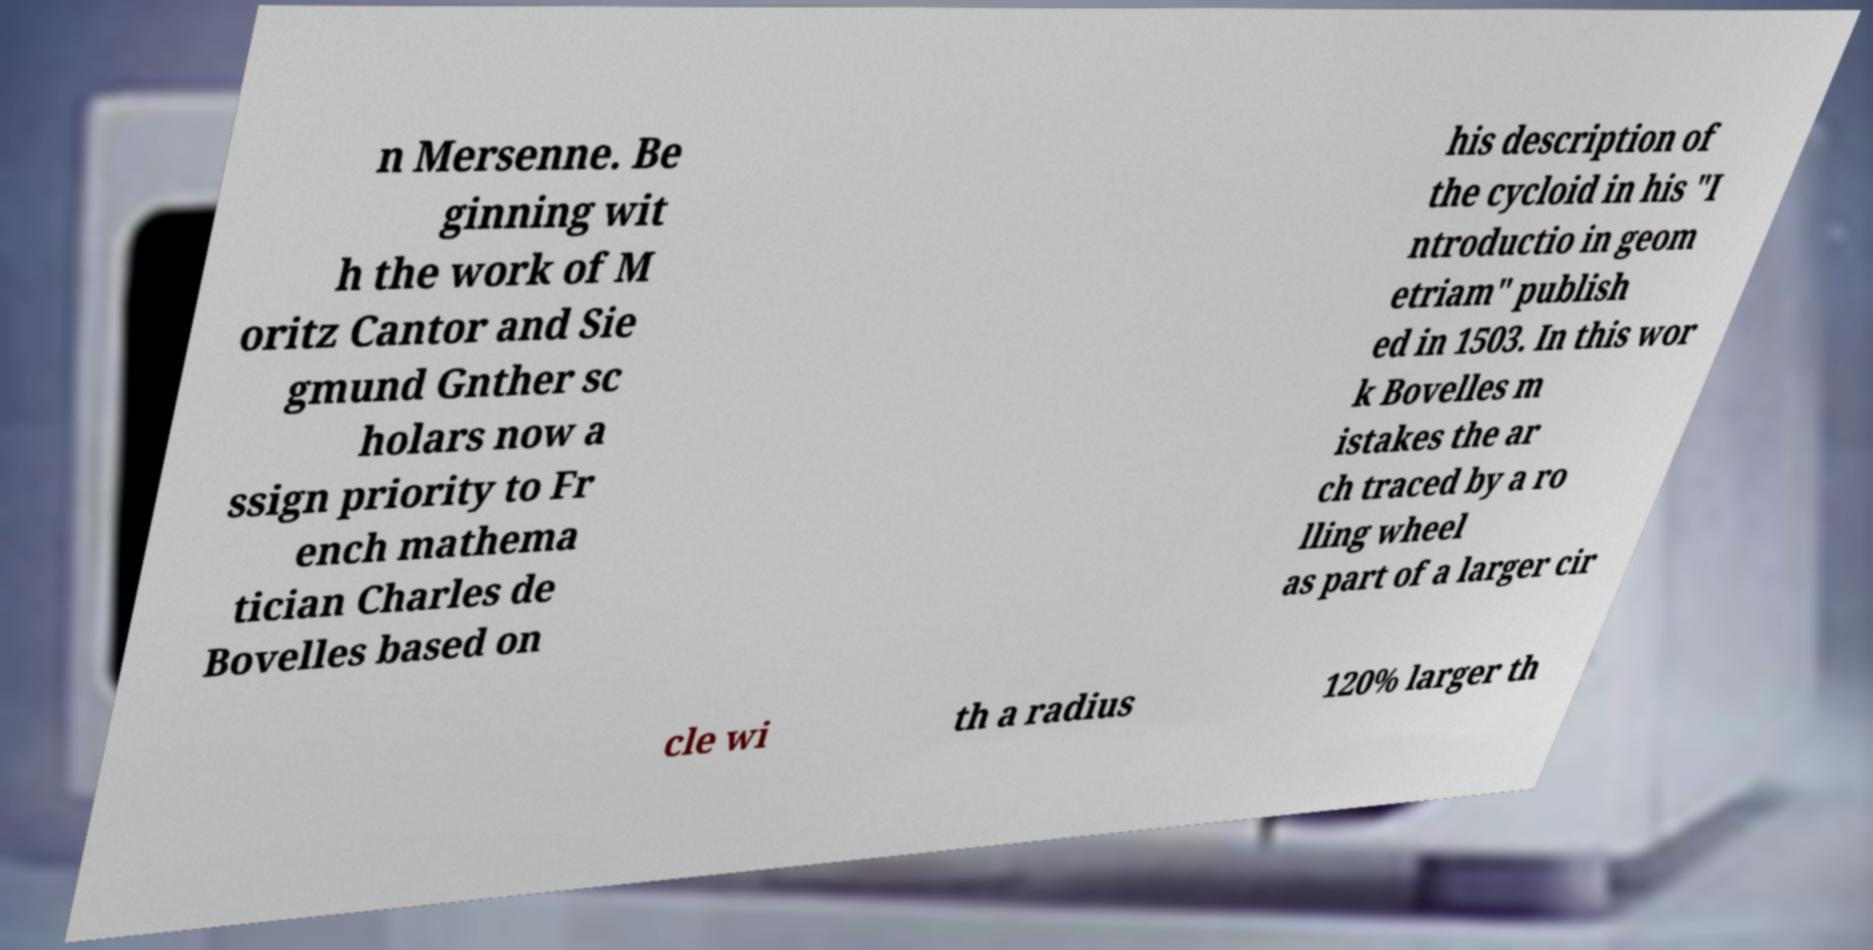Please identify and transcribe the text found in this image. n Mersenne. Be ginning wit h the work of M oritz Cantor and Sie gmund Gnther sc holars now a ssign priority to Fr ench mathema tician Charles de Bovelles based on his description of the cycloid in his "I ntroductio in geom etriam" publish ed in 1503. In this wor k Bovelles m istakes the ar ch traced by a ro lling wheel as part of a larger cir cle wi th a radius 120% larger th 